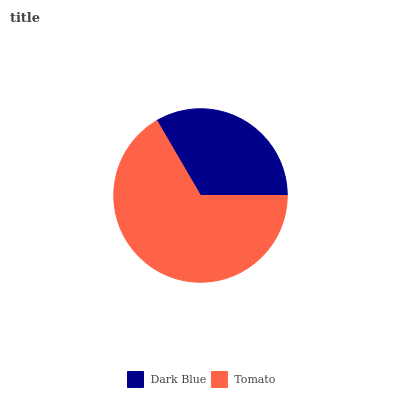Is Dark Blue the minimum?
Answer yes or no. Yes. Is Tomato the maximum?
Answer yes or no. Yes. Is Tomato the minimum?
Answer yes or no. No. Is Tomato greater than Dark Blue?
Answer yes or no. Yes. Is Dark Blue less than Tomato?
Answer yes or no. Yes. Is Dark Blue greater than Tomato?
Answer yes or no. No. Is Tomato less than Dark Blue?
Answer yes or no. No. Is Tomato the high median?
Answer yes or no. Yes. Is Dark Blue the low median?
Answer yes or no. Yes. Is Dark Blue the high median?
Answer yes or no. No. Is Tomato the low median?
Answer yes or no. No. 